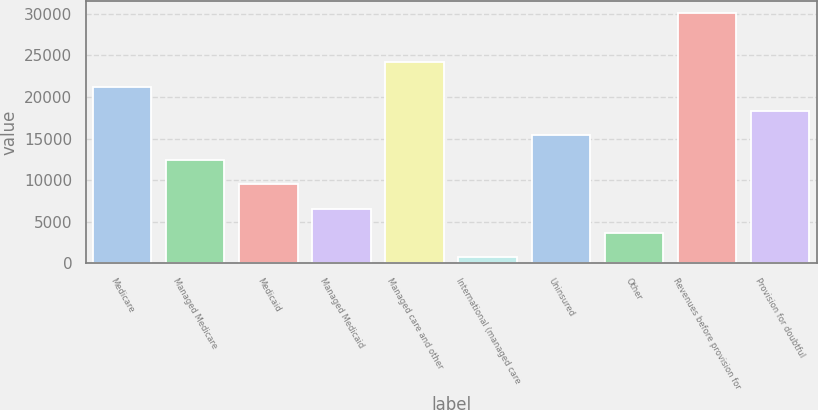Convert chart to OTSL. <chart><loc_0><loc_0><loc_500><loc_500><bar_chart><fcel>Medicare<fcel>Managed Medicare<fcel>Medicaid<fcel>Managed Medicaid<fcel>Managed care and other<fcel>International (managed care<fcel>Uninsured<fcel>Other<fcel>Revenues before provision for<fcel>Provision for doubtful<nl><fcel>21247<fcel>12442<fcel>9507<fcel>6572<fcel>24182<fcel>702<fcel>15377<fcel>3637<fcel>30052<fcel>18312<nl></chart> 